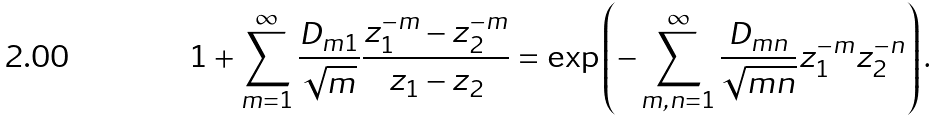<formula> <loc_0><loc_0><loc_500><loc_500>1 + \sum _ { m = 1 } ^ { \infty } \frac { D _ { m 1 } } { \sqrt { m } } \frac { z _ { 1 } ^ { - m } - z _ { 2 } ^ { - m } } { z _ { 1 } - z _ { 2 } } = \exp \left ( - \sum _ { m , n = 1 } ^ { \infty } \frac { D _ { m n } } { \sqrt { m n } } z _ { 1 } ^ { - m } z _ { 2 } ^ { - n } \right ) .</formula> 